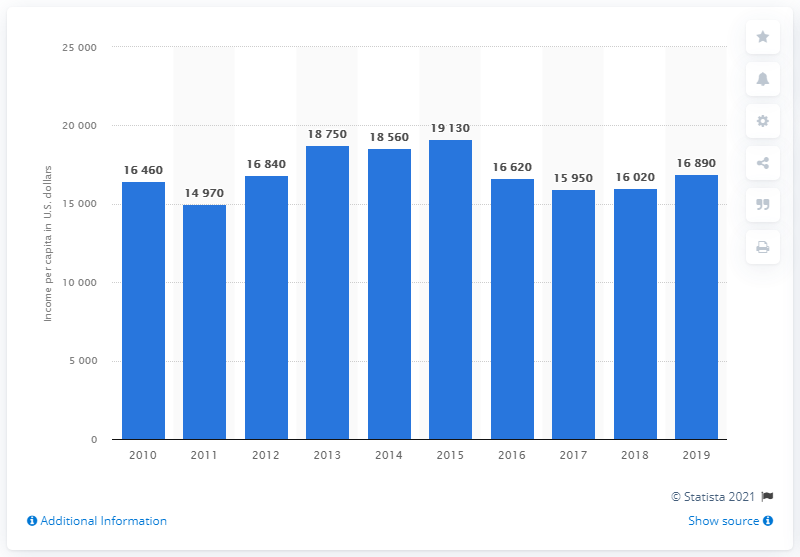Draw attention to some important aspects in this diagram. According to data from 2019, the national gross income per capita in Trinidad and Tobago was approximately 16,890 US dollars. According to the previous year's figures, Trinidad and Tobago's national gross income per person was 16,020. 